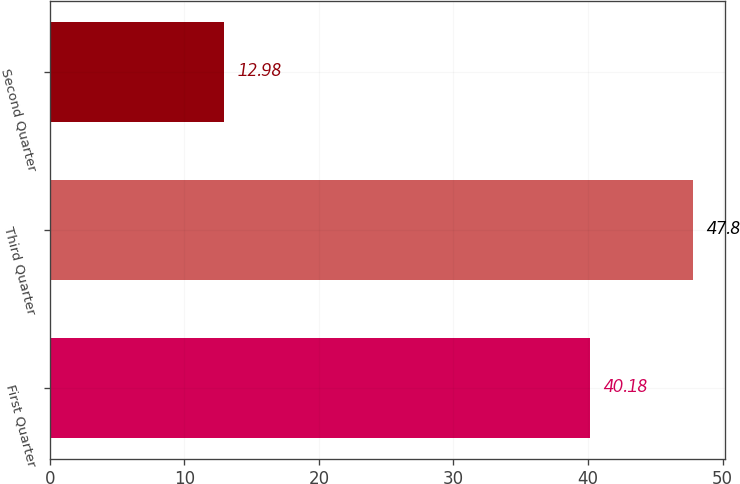Convert chart. <chart><loc_0><loc_0><loc_500><loc_500><bar_chart><fcel>First Quarter<fcel>Third Quarter<fcel>Second Quarter<nl><fcel>40.18<fcel>47.8<fcel>12.98<nl></chart> 